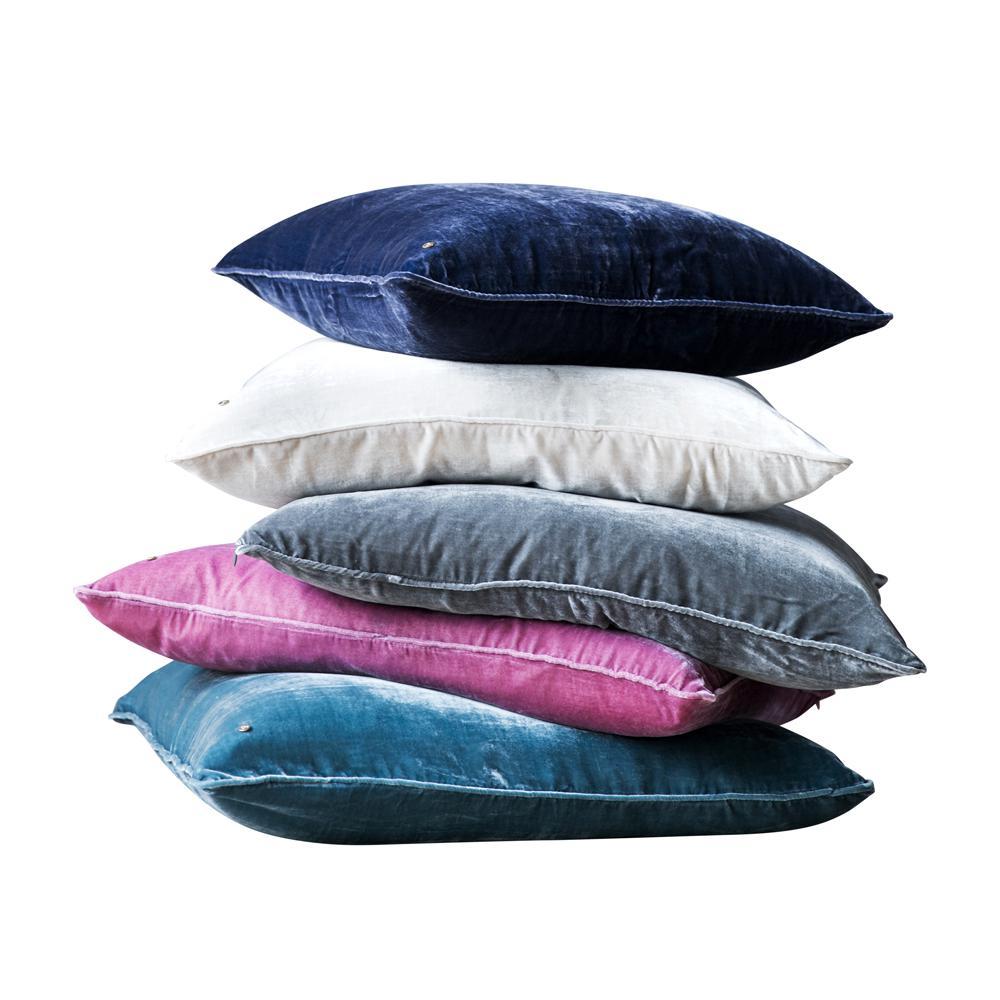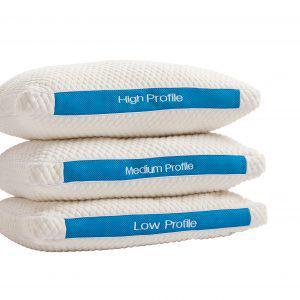The first image is the image on the left, the second image is the image on the right. Evaluate the accuracy of this statement regarding the images: "A pillow stack includes a pinkish-violet pillow the second from the bottom.". Is it true? Answer yes or no. Yes. The first image is the image on the left, the second image is the image on the right. Examine the images to the left and right. Is the description "There are at most 7 pillows in the pair of images." accurate? Answer yes or no. No. 